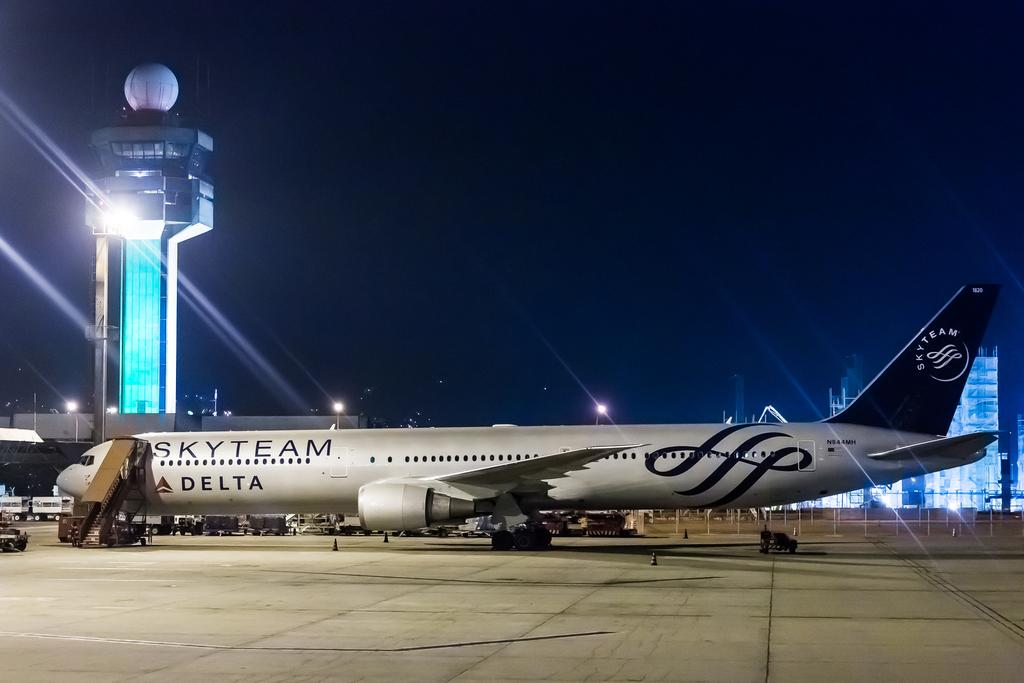<image>
Render a clear and concise summary of the photo. A Delta airline plane is pulled up to a gate at an airport. 